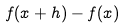Convert formula to latex. <formula><loc_0><loc_0><loc_500><loc_500>f ( x + h ) - f ( x )</formula> 